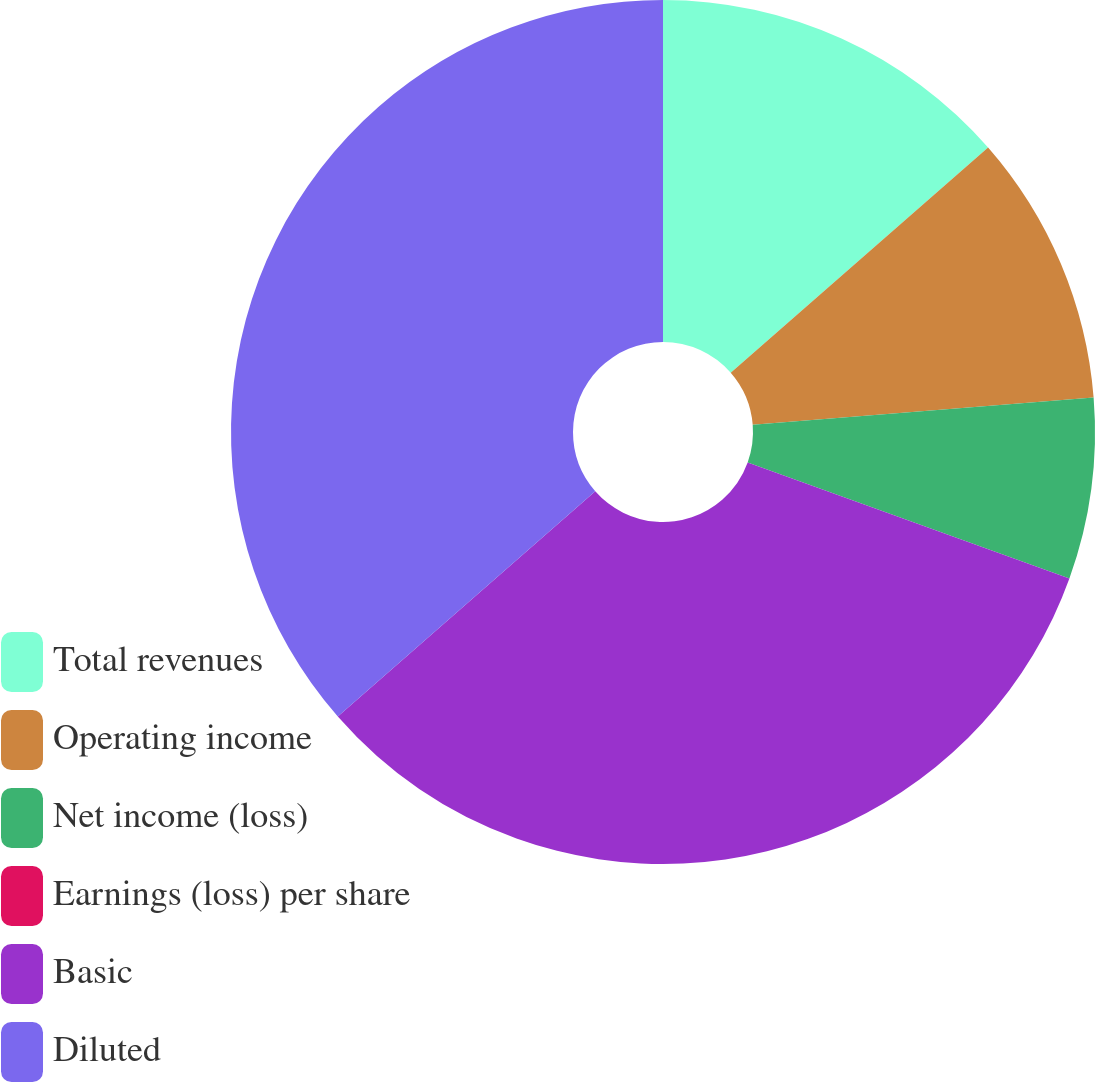<chart> <loc_0><loc_0><loc_500><loc_500><pie_chart><fcel>Total revenues<fcel>Operating income<fcel>Net income (loss)<fcel>Earnings (loss) per share<fcel>Basic<fcel>Diluted<nl><fcel>13.56%<fcel>10.17%<fcel>6.78%<fcel>0.0%<fcel>33.06%<fcel>36.44%<nl></chart> 